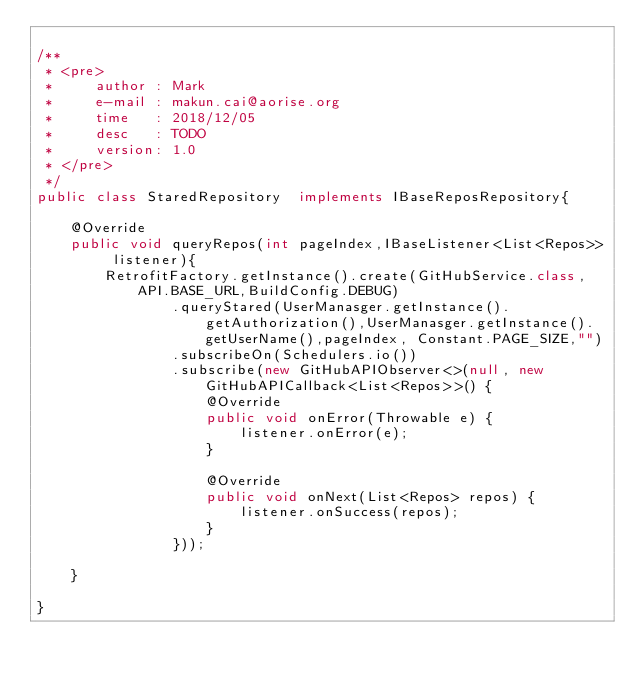Convert code to text. <code><loc_0><loc_0><loc_500><loc_500><_Java_>
/**
 * <pre>
 *     author : Mark
 *     e-mail : makun.cai@aorise.org
 *     time   : 2018/12/05
 *     desc   : TODO
 *     version: 1.0
 * </pre>
 */
public class StaredRepository  implements IBaseReposRepository{

    @Override
    public void queryRepos(int pageIndex,IBaseListener<List<Repos>> listener){
        RetrofitFactory.getInstance().create(GitHubService.class, API.BASE_URL,BuildConfig.DEBUG)
                .queryStared(UserManasger.getInstance().getAuthorization(),UserManasger.getInstance().getUserName(),pageIndex, Constant.PAGE_SIZE,"")
                .subscribeOn(Schedulers.io())
                .subscribe(new GitHubAPIObserver<>(null, new GitHubAPICallback<List<Repos>>() {
                    @Override
                    public void onError(Throwable e) {
                        listener.onError(e);
                    }

                    @Override
                    public void onNext(List<Repos> repos) {
                        listener.onSuccess(repos);
                    }
                }));

    }

}
</code> 